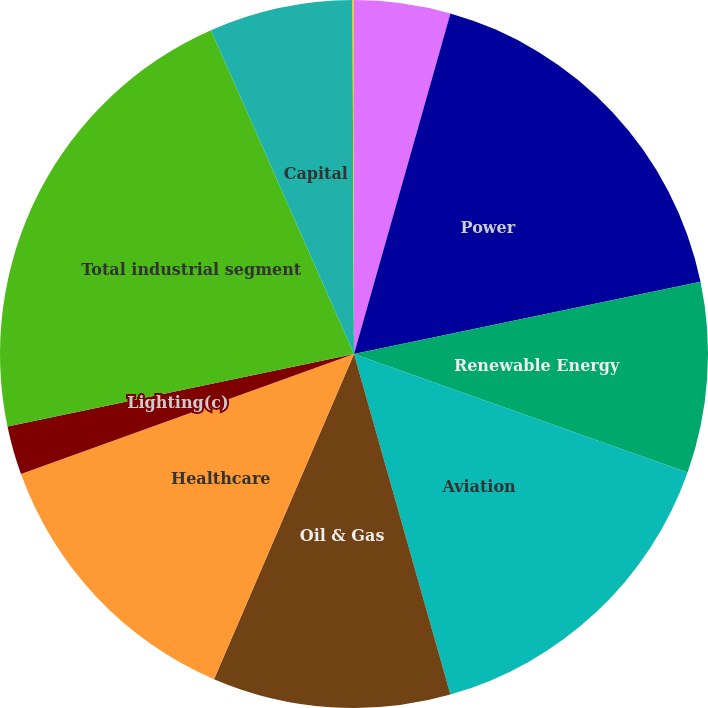Convert chart to OTSL. <chart><loc_0><loc_0><loc_500><loc_500><pie_chart><fcel>REVENUES (In millions)<fcel>Power<fcel>Renewable Energy<fcel>Aviation<fcel>Oil & Gas<fcel>Healthcare<fcel>Lighting(c)<fcel>Total industrial segment<fcel>Capital<fcel>Corporate items and<nl><fcel>4.39%<fcel>17.34%<fcel>8.7%<fcel>15.18%<fcel>10.86%<fcel>13.02%<fcel>2.23%<fcel>21.66%<fcel>6.55%<fcel>0.07%<nl></chart> 